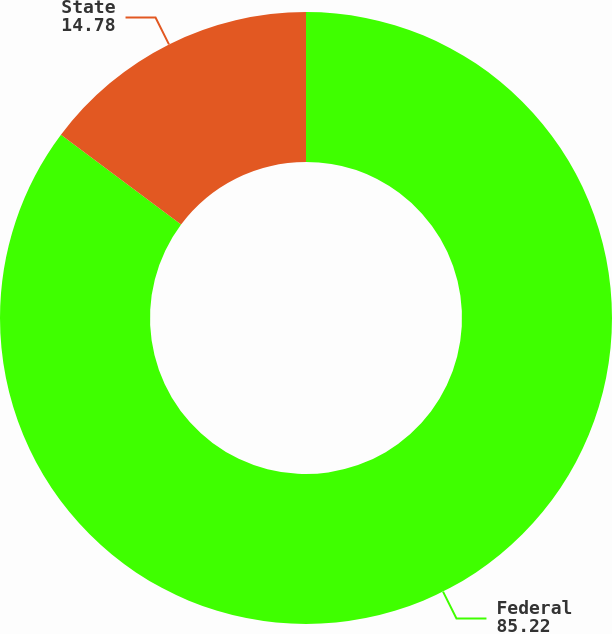<chart> <loc_0><loc_0><loc_500><loc_500><pie_chart><fcel>Federal<fcel>State<nl><fcel>85.22%<fcel>14.78%<nl></chart> 